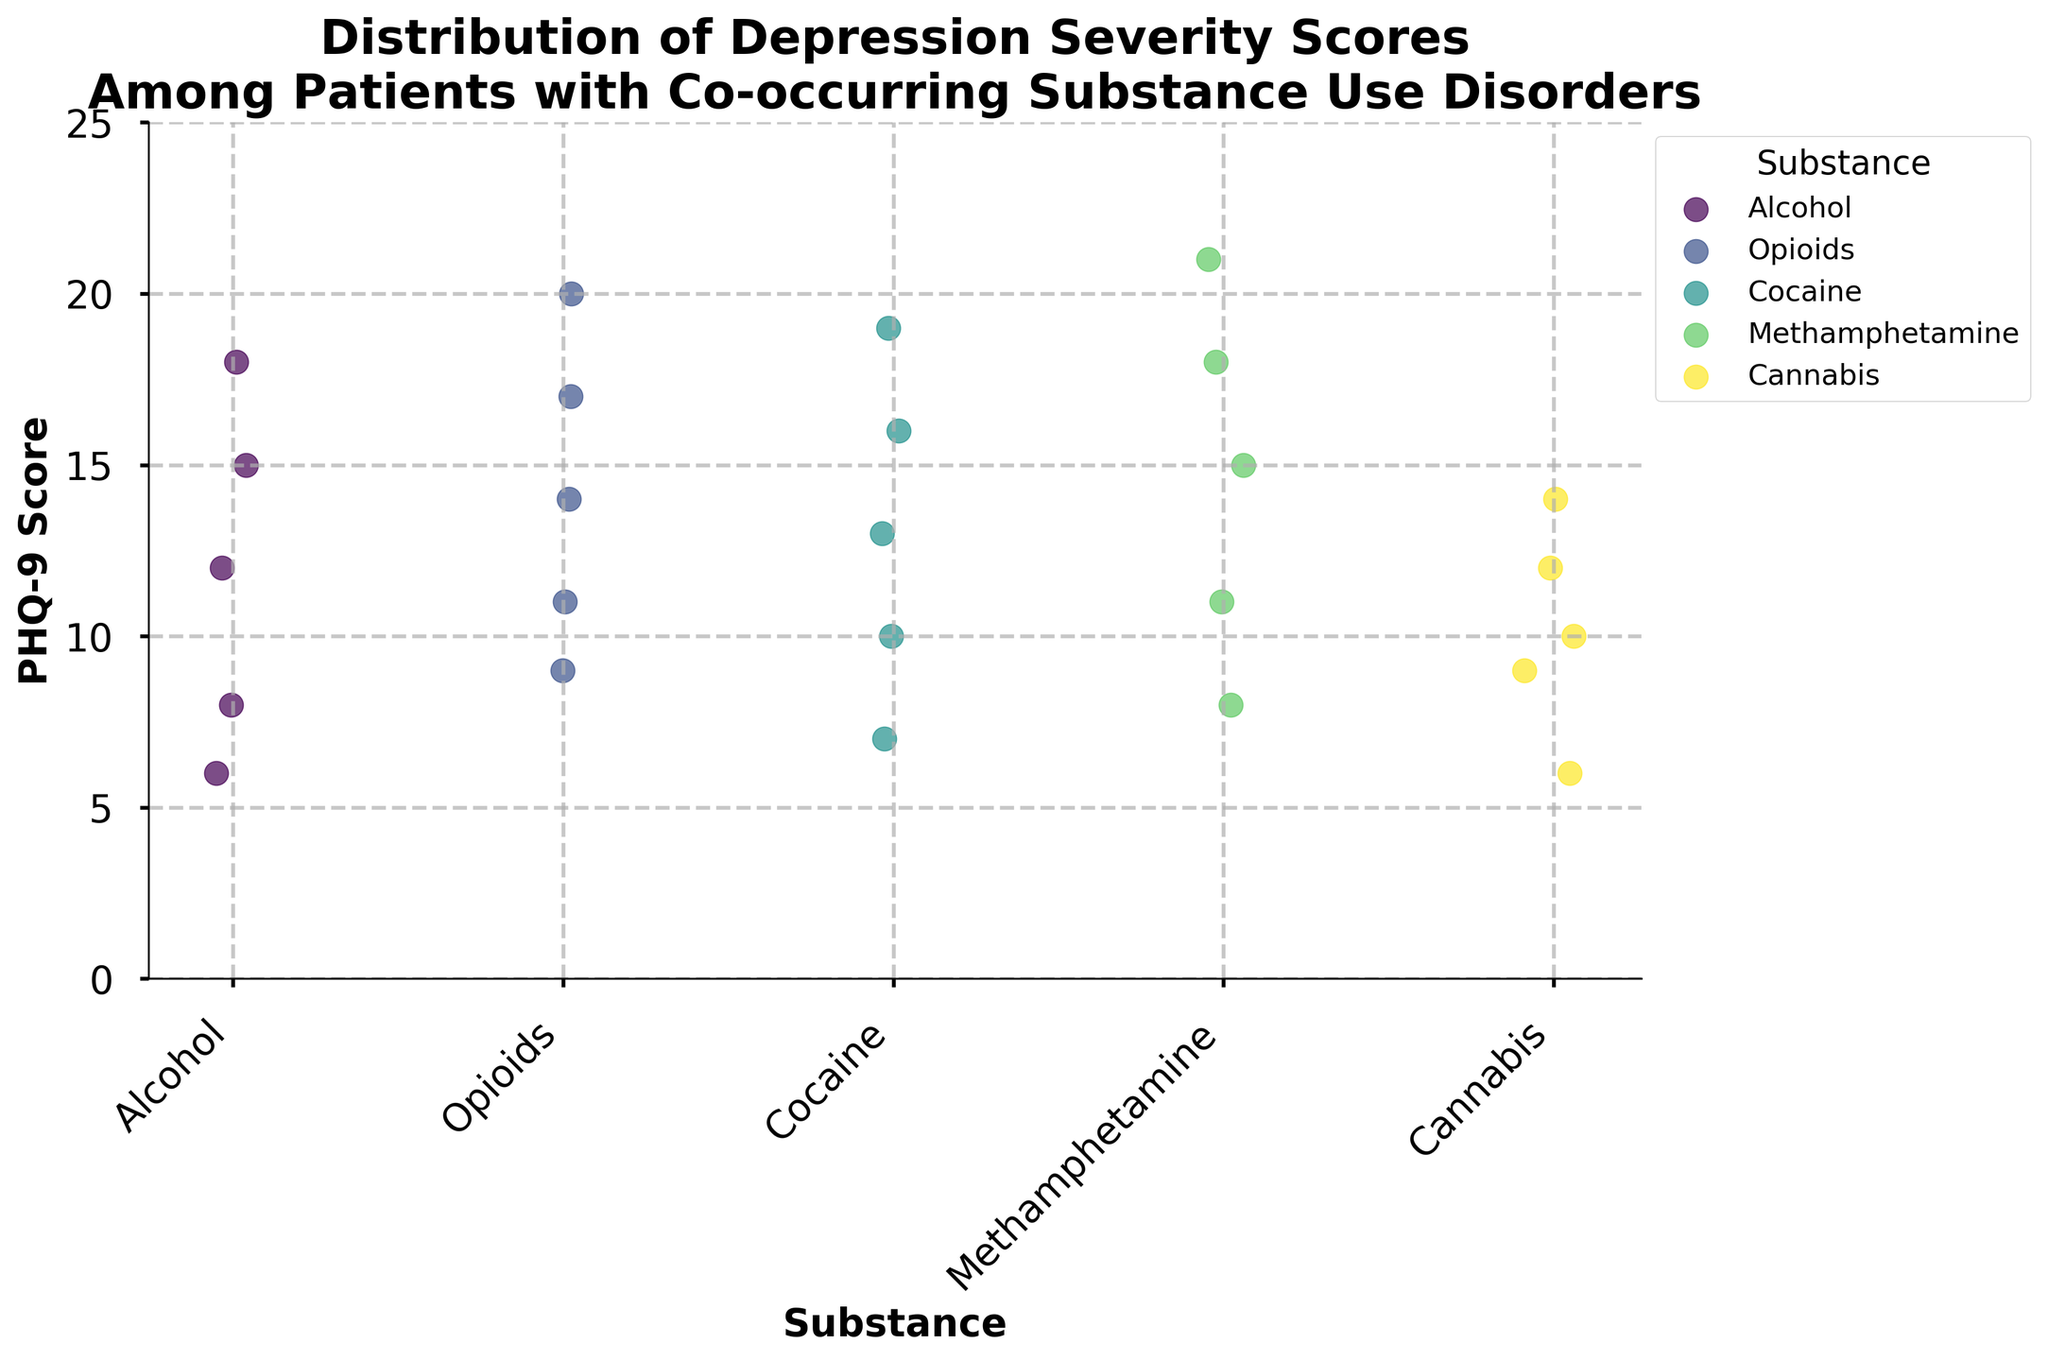What is the title of the plot? The title is usually displayed at the top of the plot, summarizing the main topic of the figure. In this case, it should reference the distribution of depression severity scores among patients with co-occurring substance use disorders.
Answer: Distribution of Depression Severity Scores Among Patients with Co-occurring Substance Use Disorders Which substance group has the highest PHQ-9 score? By looking at the vertical axis for the PHQ-9 score and identifying the highest point, we see that Methamphetamine has a maximum score of 21.
Answer: Methamphetamine How many PHQ-9 scores are plotted for each substance group? Each substance group is marked with dots representing data points. Counting the dots for each group reveals that there are 5 scores per substance group (Alcohol, Opioids, Cocaine, Methamphetamine, Cannabis).
Answer: 5 Which substance has the lowest median PHQ-9 score? The median score is the middle value when arranged in ascending order. By inspecting the plot, Cannabis has a median score lower than the others, visually around 10.
Answer: Cannabis Which substance groups have any PHQ-9 scores greater than or equal to 15? By observing the scatter points, we identify that Alcohol, Opioids, Cocaine, Methamphetamine, and Cannabis have scores greater than or equal to 15.
Answer: Alcohol, Opioids, Cocaine, Methamphetamine, Cannabis Which substance has the most variability in PHQ-9 scores? Variability can be assessed by the spread of the data points. Methamphetamine has scores ranging from 8 to 21, indicating the most variability.
Answer: Methamphetamine What is the range of PHQ-9 scores for Opioids? The range is the difference between the highest and lowest values. For Opioids, the highest score is 20 and the lowest is 9. So, the range is 20 - 9.
Answer: 11 Which substance has the lowest score and what is that score? Identify the minimum value on the vertical axis and link it to the corresponding substance. Cannabis has the lowest score at 6.
Answer: Cannabis, 6 What is the average PHQ-9 score for Cocaine? The scores for Cocaine are 13, 7, 16, 10, 19. The average is calculated as (13 + 7 + 16 + 10 + 19) / 5 = 65 / 5 = 13.
Answer: 13 Between Opioids and Alcohol, which substance has more scores above 10? Count the number of scores above 10 for each substance. Opioids have 4 scores above 10 (14, 20, 11, 17) and Alcohol has 2 scores above 10 (12, 15).
Answer: Opioids 